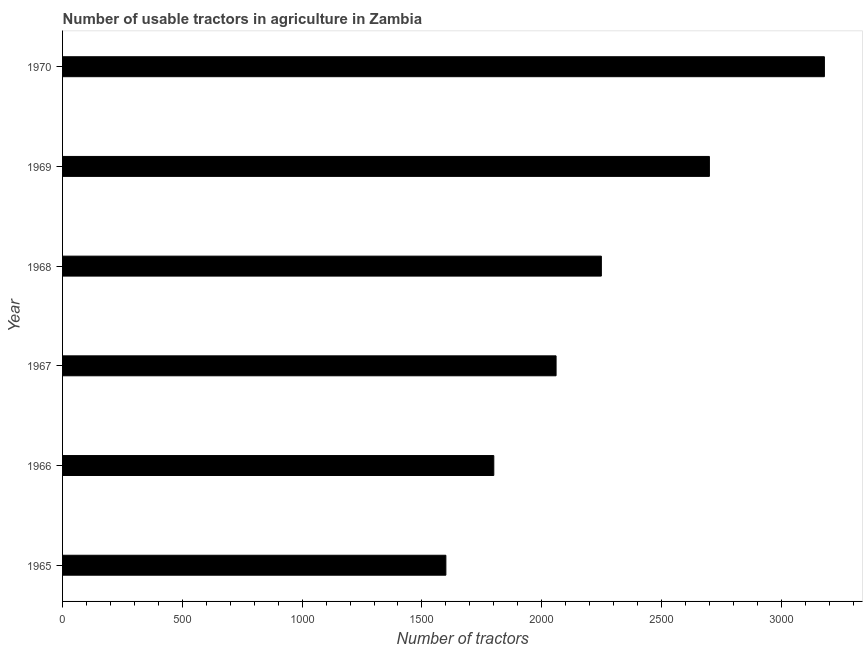Does the graph contain any zero values?
Keep it short and to the point. No. Does the graph contain grids?
Your answer should be compact. No. What is the title of the graph?
Offer a terse response. Number of usable tractors in agriculture in Zambia. What is the label or title of the X-axis?
Keep it short and to the point. Number of tractors. What is the label or title of the Y-axis?
Offer a terse response. Year. What is the number of tractors in 1970?
Your answer should be very brief. 3180. Across all years, what is the maximum number of tractors?
Offer a terse response. 3180. Across all years, what is the minimum number of tractors?
Make the answer very short. 1600. In which year was the number of tractors minimum?
Give a very brief answer. 1965. What is the sum of the number of tractors?
Offer a very short reply. 1.36e+04. What is the difference between the number of tractors in 1966 and 1968?
Your answer should be very brief. -449. What is the average number of tractors per year?
Provide a short and direct response. 2264. What is the median number of tractors?
Provide a succinct answer. 2154.5. In how many years, is the number of tractors greater than 500 ?
Offer a terse response. 6. What is the ratio of the number of tractors in 1966 to that in 1967?
Keep it short and to the point. 0.87. Is the number of tractors in 1967 less than that in 1970?
Keep it short and to the point. Yes. What is the difference between the highest and the second highest number of tractors?
Provide a short and direct response. 480. Is the sum of the number of tractors in 1967 and 1968 greater than the maximum number of tractors across all years?
Your response must be concise. Yes. What is the difference between the highest and the lowest number of tractors?
Make the answer very short. 1580. In how many years, is the number of tractors greater than the average number of tractors taken over all years?
Keep it short and to the point. 2. How many bars are there?
Give a very brief answer. 6. Are all the bars in the graph horizontal?
Ensure brevity in your answer.  Yes. Are the values on the major ticks of X-axis written in scientific E-notation?
Keep it short and to the point. No. What is the Number of tractors of 1965?
Ensure brevity in your answer.  1600. What is the Number of tractors in 1966?
Your answer should be compact. 1800. What is the Number of tractors in 1967?
Offer a terse response. 2060. What is the Number of tractors of 1968?
Ensure brevity in your answer.  2249. What is the Number of tractors in 1969?
Keep it short and to the point. 2700. What is the Number of tractors of 1970?
Provide a succinct answer. 3180. What is the difference between the Number of tractors in 1965 and 1966?
Provide a succinct answer. -200. What is the difference between the Number of tractors in 1965 and 1967?
Offer a very short reply. -460. What is the difference between the Number of tractors in 1965 and 1968?
Keep it short and to the point. -649. What is the difference between the Number of tractors in 1965 and 1969?
Provide a succinct answer. -1100. What is the difference between the Number of tractors in 1965 and 1970?
Make the answer very short. -1580. What is the difference between the Number of tractors in 1966 and 1967?
Keep it short and to the point. -260. What is the difference between the Number of tractors in 1966 and 1968?
Ensure brevity in your answer.  -449. What is the difference between the Number of tractors in 1966 and 1969?
Offer a very short reply. -900. What is the difference between the Number of tractors in 1966 and 1970?
Your answer should be compact. -1380. What is the difference between the Number of tractors in 1967 and 1968?
Ensure brevity in your answer.  -189. What is the difference between the Number of tractors in 1967 and 1969?
Your answer should be compact. -640. What is the difference between the Number of tractors in 1967 and 1970?
Offer a very short reply. -1120. What is the difference between the Number of tractors in 1968 and 1969?
Your response must be concise. -451. What is the difference between the Number of tractors in 1968 and 1970?
Provide a succinct answer. -931. What is the difference between the Number of tractors in 1969 and 1970?
Your answer should be compact. -480. What is the ratio of the Number of tractors in 1965 to that in 1966?
Your answer should be compact. 0.89. What is the ratio of the Number of tractors in 1965 to that in 1967?
Make the answer very short. 0.78. What is the ratio of the Number of tractors in 1965 to that in 1968?
Your response must be concise. 0.71. What is the ratio of the Number of tractors in 1965 to that in 1969?
Give a very brief answer. 0.59. What is the ratio of the Number of tractors in 1965 to that in 1970?
Your response must be concise. 0.5. What is the ratio of the Number of tractors in 1966 to that in 1967?
Provide a short and direct response. 0.87. What is the ratio of the Number of tractors in 1966 to that in 1968?
Make the answer very short. 0.8. What is the ratio of the Number of tractors in 1966 to that in 1969?
Your response must be concise. 0.67. What is the ratio of the Number of tractors in 1966 to that in 1970?
Offer a terse response. 0.57. What is the ratio of the Number of tractors in 1967 to that in 1968?
Offer a very short reply. 0.92. What is the ratio of the Number of tractors in 1967 to that in 1969?
Offer a terse response. 0.76. What is the ratio of the Number of tractors in 1967 to that in 1970?
Offer a very short reply. 0.65. What is the ratio of the Number of tractors in 1968 to that in 1969?
Provide a succinct answer. 0.83. What is the ratio of the Number of tractors in 1968 to that in 1970?
Provide a succinct answer. 0.71. What is the ratio of the Number of tractors in 1969 to that in 1970?
Make the answer very short. 0.85. 